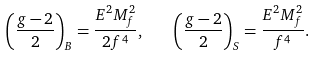Convert formula to latex. <formula><loc_0><loc_0><loc_500><loc_500>\left ( \frac { g - 2 } { 2 } \right ) _ { B } = \frac { E ^ { 2 } M _ { f } ^ { 2 } } { 2 f ^ { 4 } } , \quad \left ( \frac { g - 2 } { 2 } \right ) _ { S } = \frac { E ^ { 2 } M _ { f } ^ { 2 } } { f ^ { 4 } } .</formula> 